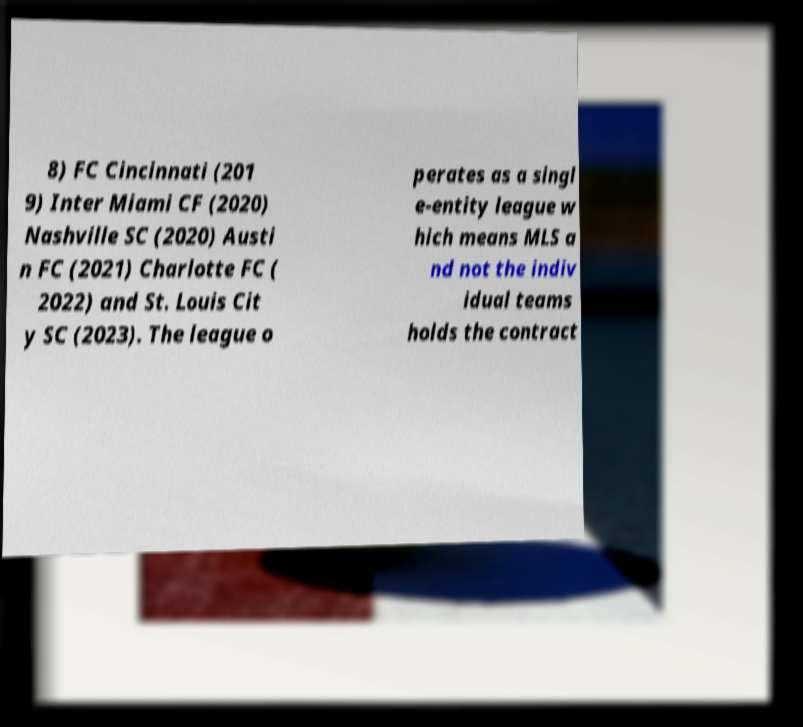There's text embedded in this image that I need extracted. Can you transcribe it verbatim? 8) FC Cincinnati (201 9) Inter Miami CF (2020) Nashville SC (2020) Austi n FC (2021) Charlotte FC ( 2022) and St. Louis Cit y SC (2023). The league o perates as a singl e-entity league w hich means MLS a nd not the indiv idual teams holds the contract 